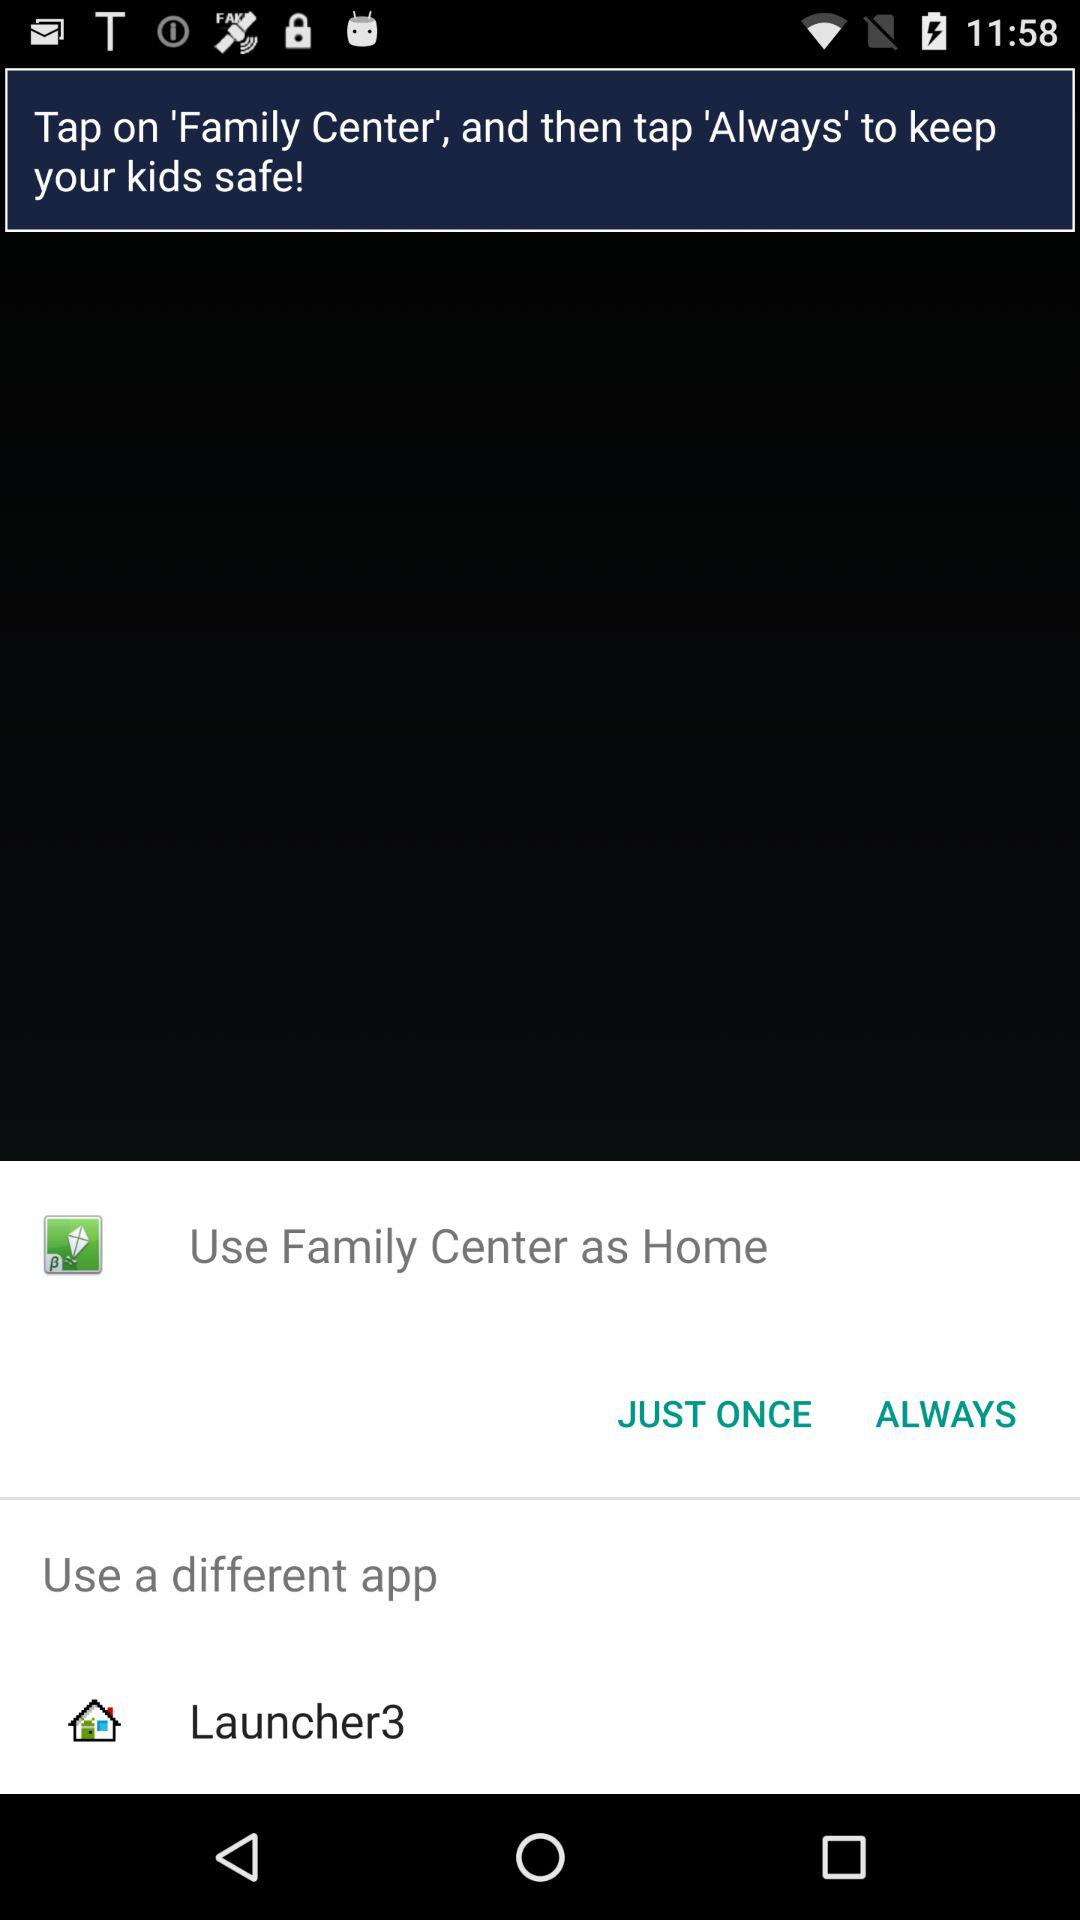Which application can be used as "Home"? The applications that can be used as "Home" are "Family Center" and "Launcher3". 